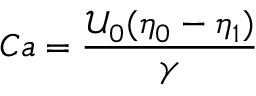<formula> <loc_0><loc_0><loc_500><loc_500>C a = \frac { \mathcal { U } _ { 0 } ( \eta _ { 0 } - \eta _ { 1 } ) } { \gamma }</formula> 